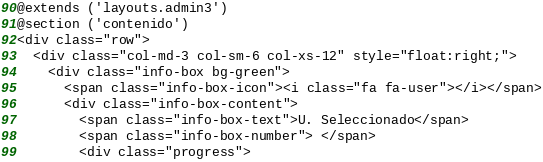<code> <loc_0><loc_0><loc_500><loc_500><_PHP_>@extends ('layouts.admin3')
@section ('contenido')
<div class="row">
  <div class="col-md-3 col-sm-6 col-xs-12" style="float:right;">
    <div class="info-box bg-green">
      <span class="info-box-icon"><i class="fa fa-user"></i></span>
      <div class="info-box-content">
        <span class="info-box-text">U. Seleccionado</span>
        <span class="info-box-number"> </span>        
        <div class="progress"></code> 